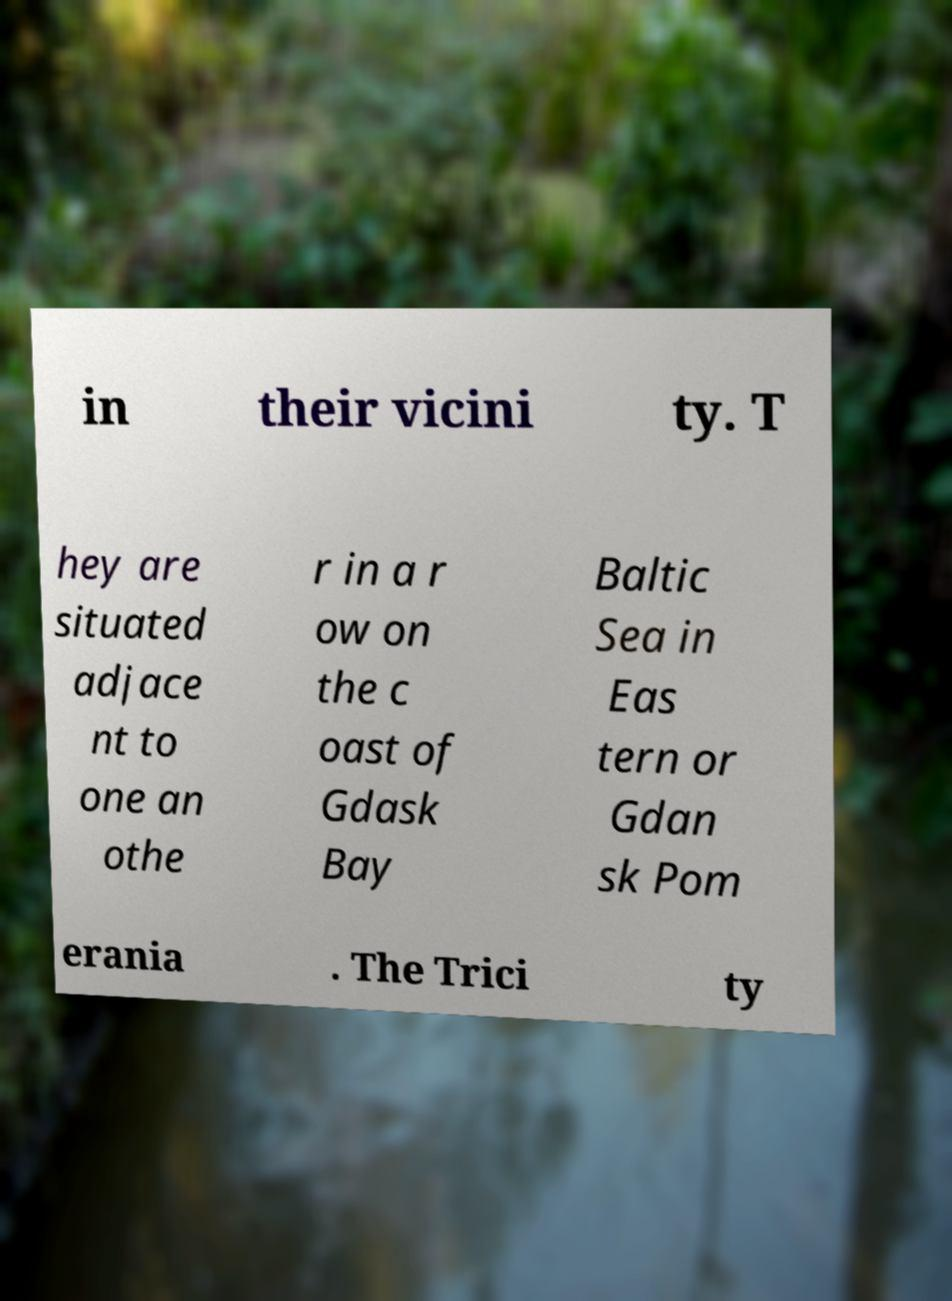Could you assist in decoding the text presented in this image and type it out clearly? in their vicini ty. T hey are situated adjace nt to one an othe r in a r ow on the c oast of Gdask Bay Baltic Sea in Eas tern or Gdan sk Pom erania . The Trici ty 